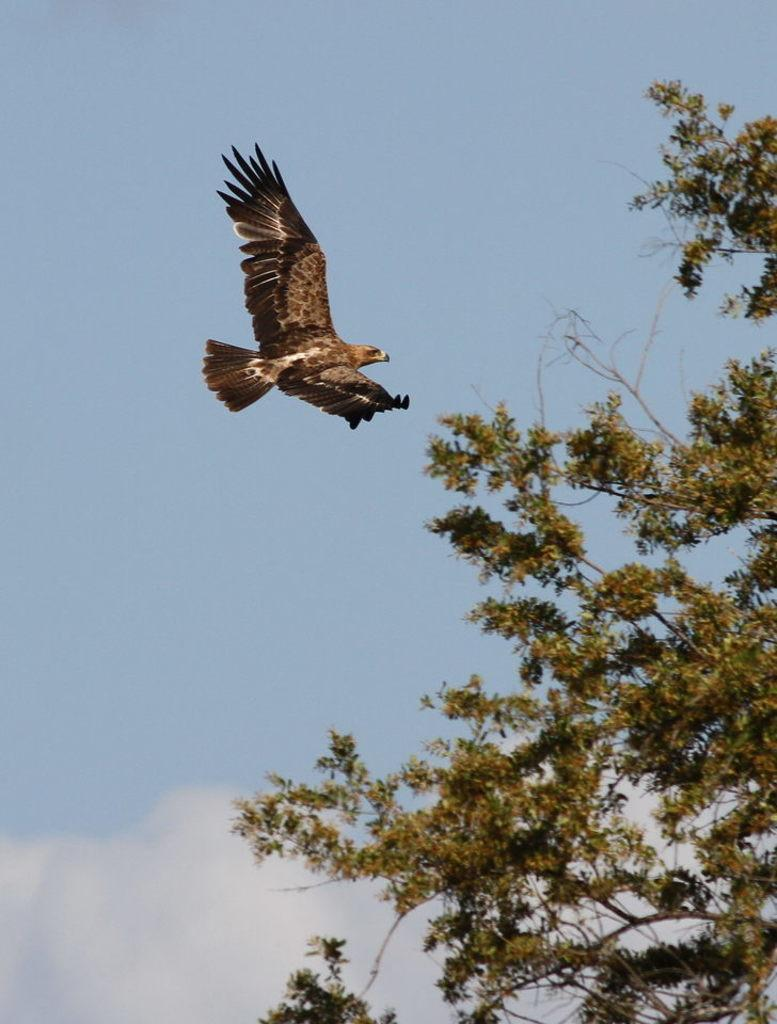What type of vegetation is on the right side of the image? There is a tree on the right side of the image. What animal can be seen in the sky in the image? An eagle is flying in the sky in the image. What type of wood is the eagle made of in the image? There is no eagle made of wood in the image; it is a live eagle flying in the sky. How many giants are present in the image? There are no giants present in the image. 